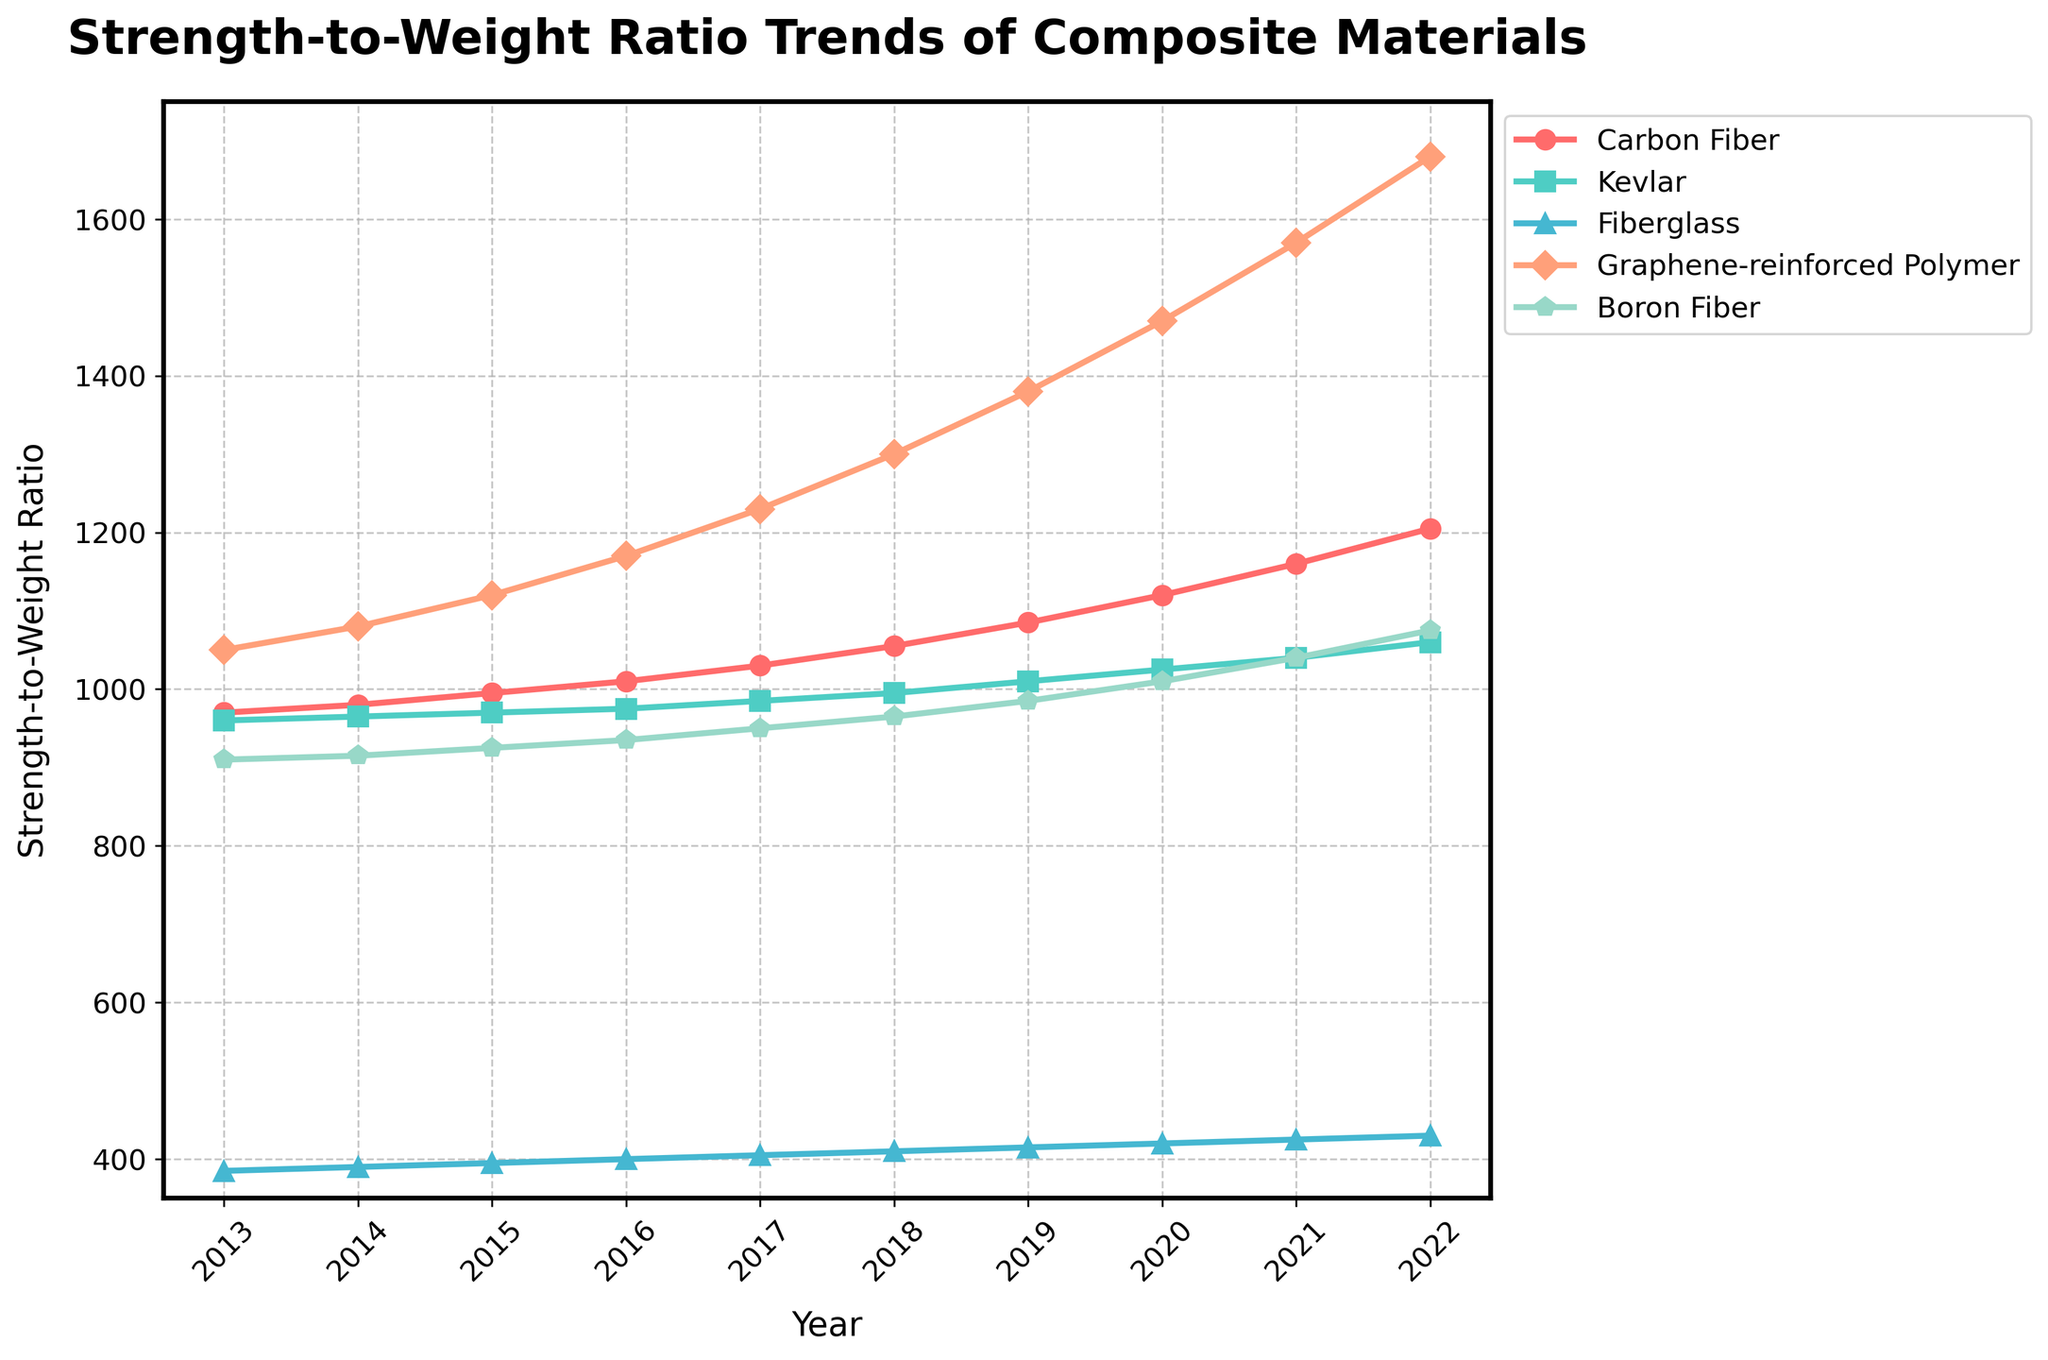What's the average strength-to-weight ratio of Carbon Fiber from 2013 to 2022? To find the average, sum up the values of Carbon Fiber from 2013 to 2022 and divide by the number of years. The sum is \(970 + 980 + 995 + 1010 + 1030 + 1055 + 1085 + 1120 + 1160 + 1205 = 10610\). There are 10 years, so the average is \(10610/10 = 1061\).
Answer: 1061 In which year did Graphene-reinforced Polymer surpass the strength-to-weight ratio of 1500? Look at the trend line for Graphene-reinforced Polymer and identify the year it first exceeds 1500. From the plot, it can be seen that it passed 1500 in 2021.
Answer: 2021 Which material had the smallest increase in strength-to-weight ratio from 2013 to 2022? Calculate the difference between the 2022 and 2013 values for each material. Carbon Fiber increased by \(1205 - 970 = 235\), Kevlar by \(1060 - 960 = 100\), Fiberglass by \(430 - 385 = 45\), Graphene-reinforced Polymer by \(1680 - 1050 = 630\), and Boron Fiber by \(1075 - 910 = 165\). The smallest increase is for Fiberglass.
Answer: Fiberglass By how much did the strength-to-weight ratio of Boron Fiber grow from 2017 to 2022? Subtract the 2017 value for Boron Fiber from its 2022 value, which is \(1075 - 950 = 125\).
Answer: 125 Which material shows the steepest growth trend over the decade? Visual inspection of the slopes of the trend lines indicates that Graphene-reinforced Polymer has the steepest growth, demonstrated by its rapid increase over the years.
Answer: Graphene-reinforced Polymer How many materials reached a strength-to-weight ratio above 1000 by 2020? Identify the materials that had values above 1000 in 2020. The values for 2020 are Carbon Fiber (1120), Kevlar (1025), Fiberglass (420), Graphene-reinforced Polymer (1470), and Boron Fiber (1010). Thus, the count is 4 materials.
Answer: 4 What is the difference in the strength-to-weight ratio between Carbon Fiber and Kevlar in 2022? Subtract Kevlar’s 2022 value from Carbon Fiber's 2022 value, \(1205 - 1060 = 145\).
Answer: 145 What is the median strength-to-weight ratio value of Fiberglass over the decade? To find the median, list the yearly values \(385, 390, 395, 400, 405, 410, 415, 420, 425, 430\) and find the middle value. Since there are 10 observations, the median is the average of the 5th and 6th values: \((405 + 410) / 2 = 407.5\).
Answer: 407.5 Among the materials, which one consistently showed the highest strength-to-weight ratio throughout the decade? By comparing the values each year on the plot, it is evident that Graphene-reinforced Polymer consistently had the highest strength-to-weight ratio.
Answer: Graphene-reinforced Polymer 